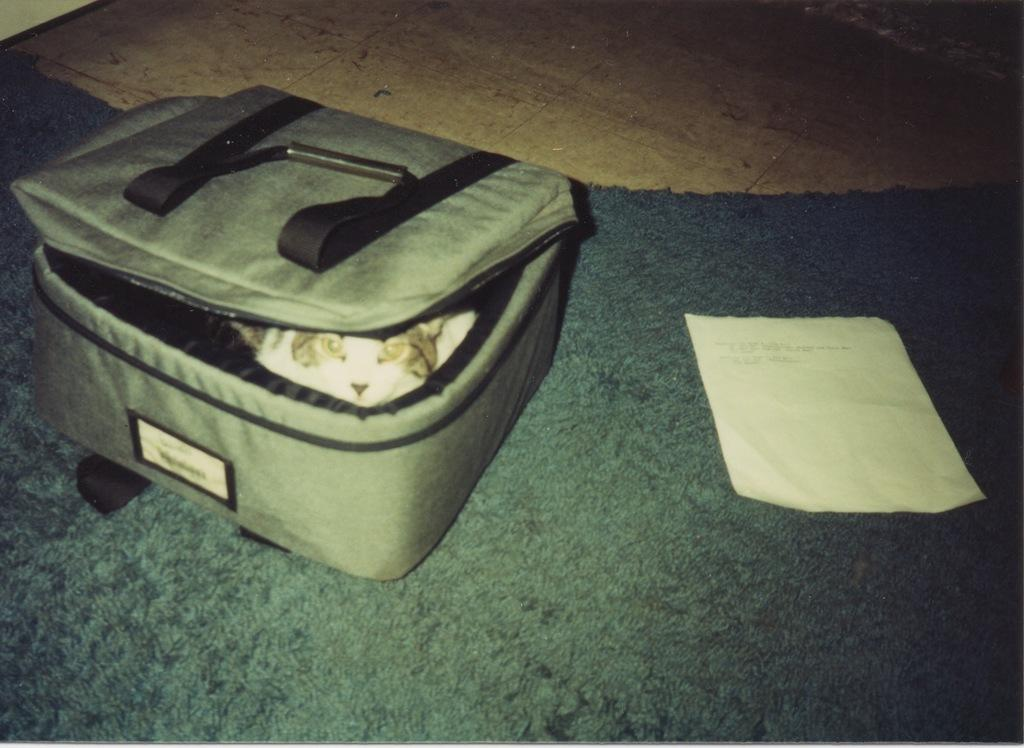What is inside the leather bag in the image? There is a cat inside a leather bag in the image. What is placed on the carpet in the image? There is a paper placed in a carpet in the image. What type of sweater is the cat wearing in the image? The cat is not wearing a sweater in the image; it is inside a leather bag. Are there any trousers visible in the image? There is no mention of trousers in the provided facts, and therefore we cannot determine if any are visible in the image. What brand of toothpaste is being advertised in the image? There is no toothpaste or advertisement present in the image. 